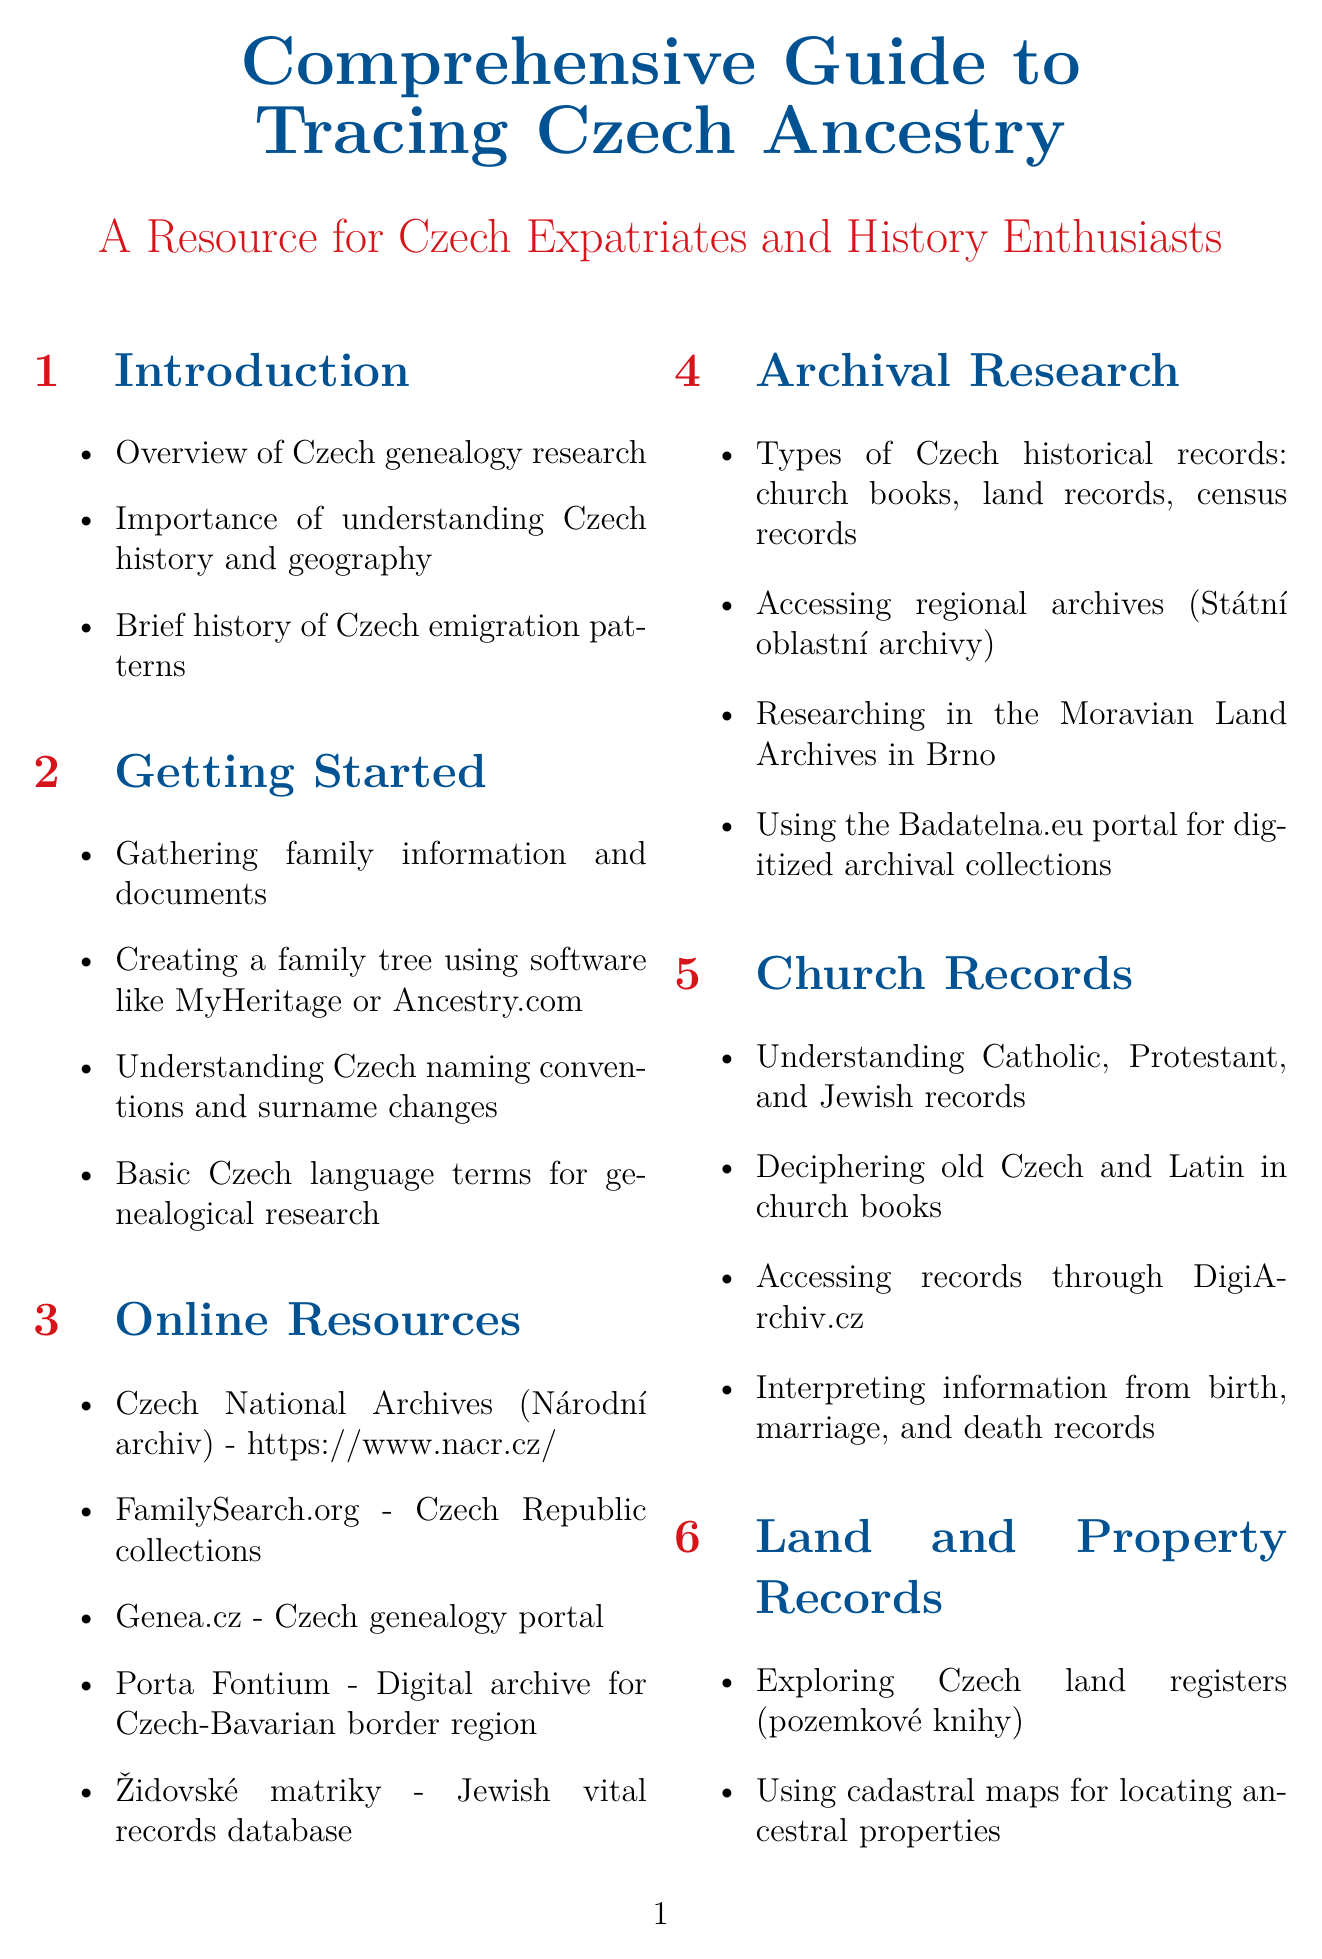What is the title of the document? The title of the document provides a clear indication of its content, which is a comprehensive guide for tracing Czech ancestry.
Answer: Comprehensive Guide to Tracing Czech Ancestry What is one online resource mentioned for accessing Czech genealogical records? The document lists several online resources, highlighting those that can assist in genealogical research.
Answer: Czech National Archives (Národní archiv) Which section covers understanding Catholic, Protestant, and Jewish records? This section specifically addresses different types of church records relevant for genealogical research.
Answer: Church Records What is one type of historical record discussed in the Archival Research section? The document discusses different types of historical records, which are crucial for conducting genealogical research.
Answer: church books How many case studies are presented in the document? The document includes specific examples to help illustrate techniques and findings in genealogy.
Answer: 3 Which software is suggested for creating a family tree? The document recommends certain software tools that facilitate family tree creation for genealogical research.
Answer: MyHeritage or Ancestry.com 